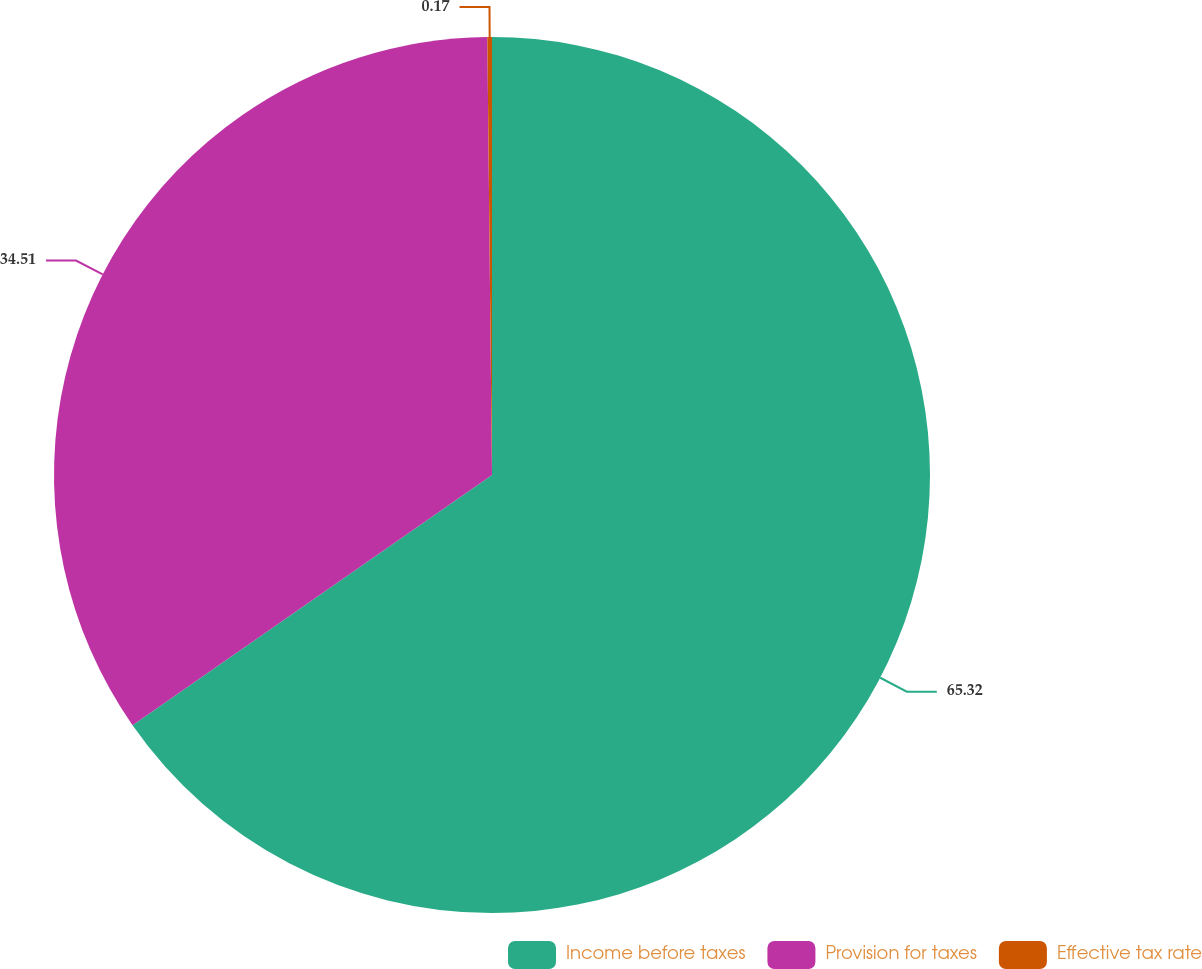Convert chart to OTSL. <chart><loc_0><loc_0><loc_500><loc_500><pie_chart><fcel>Income before taxes<fcel>Provision for taxes<fcel>Effective tax rate<nl><fcel>65.32%<fcel>34.51%<fcel>0.17%<nl></chart> 